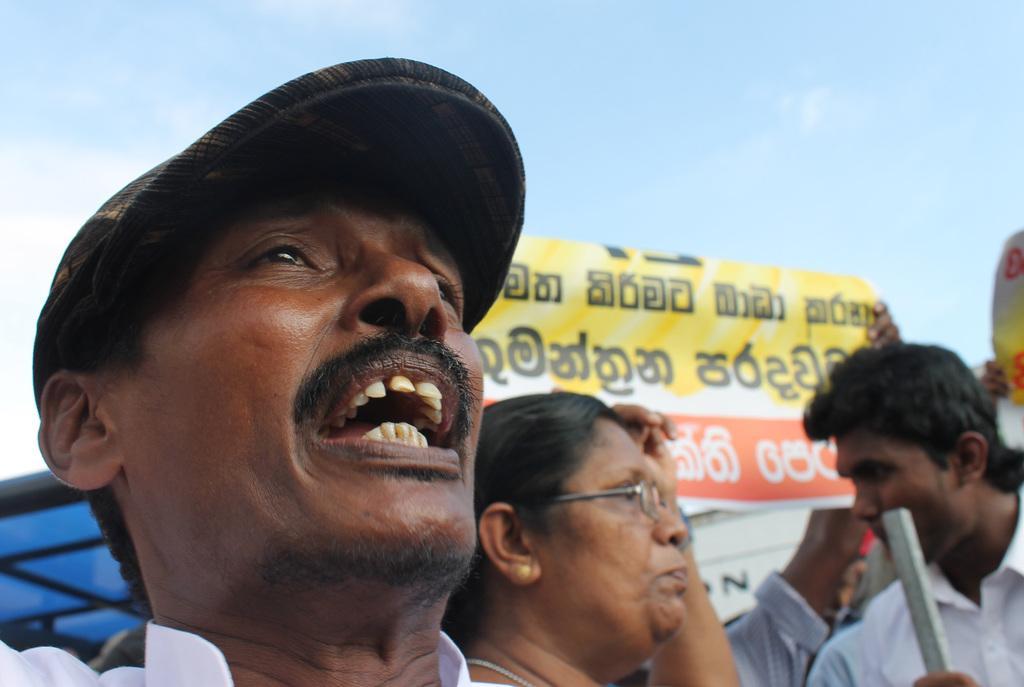Describe this image in one or two sentences. In this image I can see few people standing and holding banner. It is in yellow,red and white color. The sky is in blue and white color. 